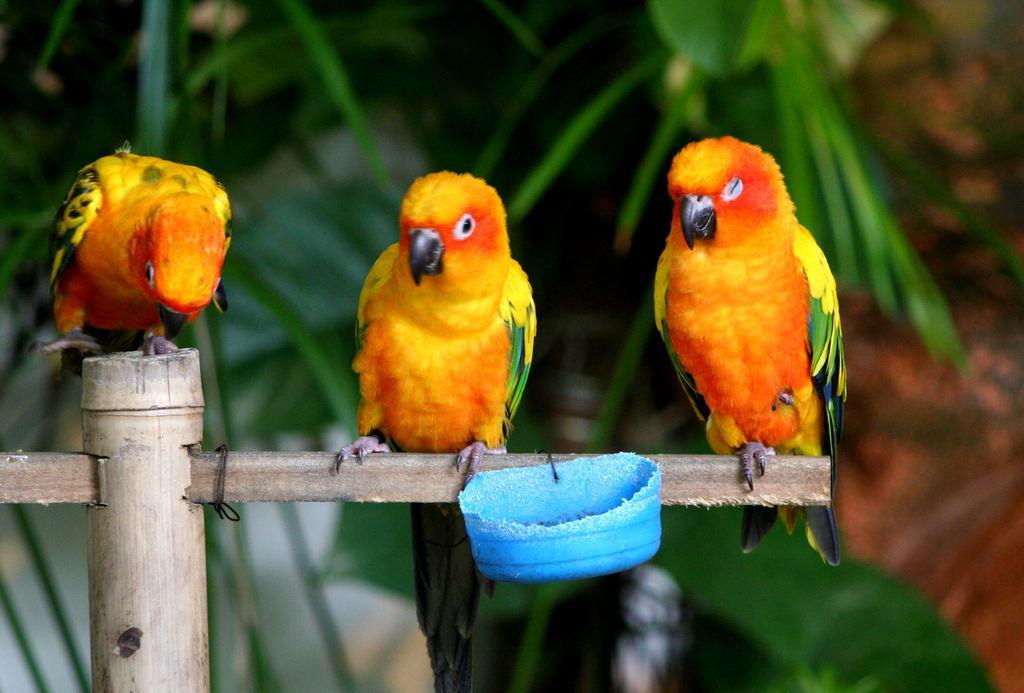How would you summarize this image in a sentence or two? In the middle of this image I can see three birds on a wooden stick and there is a small bowl attached to it. In the background few leaves are visible. 